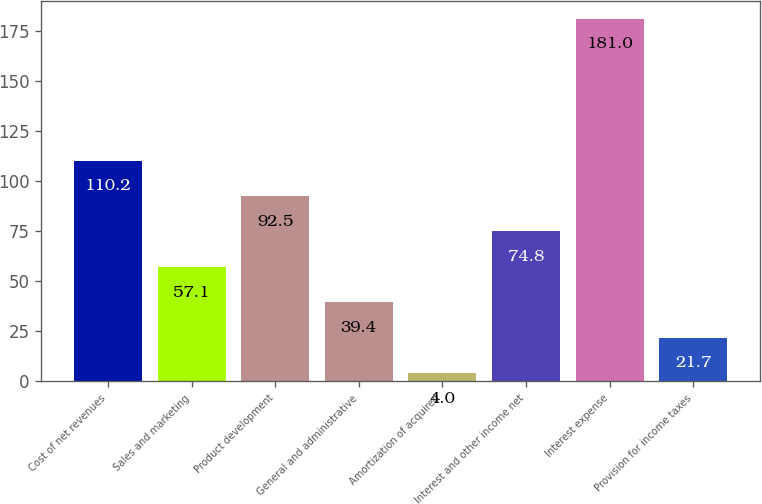Convert chart. <chart><loc_0><loc_0><loc_500><loc_500><bar_chart><fcel>Cost of net revenues<fcel>Sales and marketing<fcel>Product development<fcel>General and administrative<fcel>Amortization of acquired<fcel>Interest and other income net<fcel>Interest expense<fcel>Provision for income taxes<nl><fcel>110.2<fcel>57.1<fcel>92.5<fcel>39.4<fcel>4<fcel>74.8<fcel>181<fcel>21.7<nl></chart> 